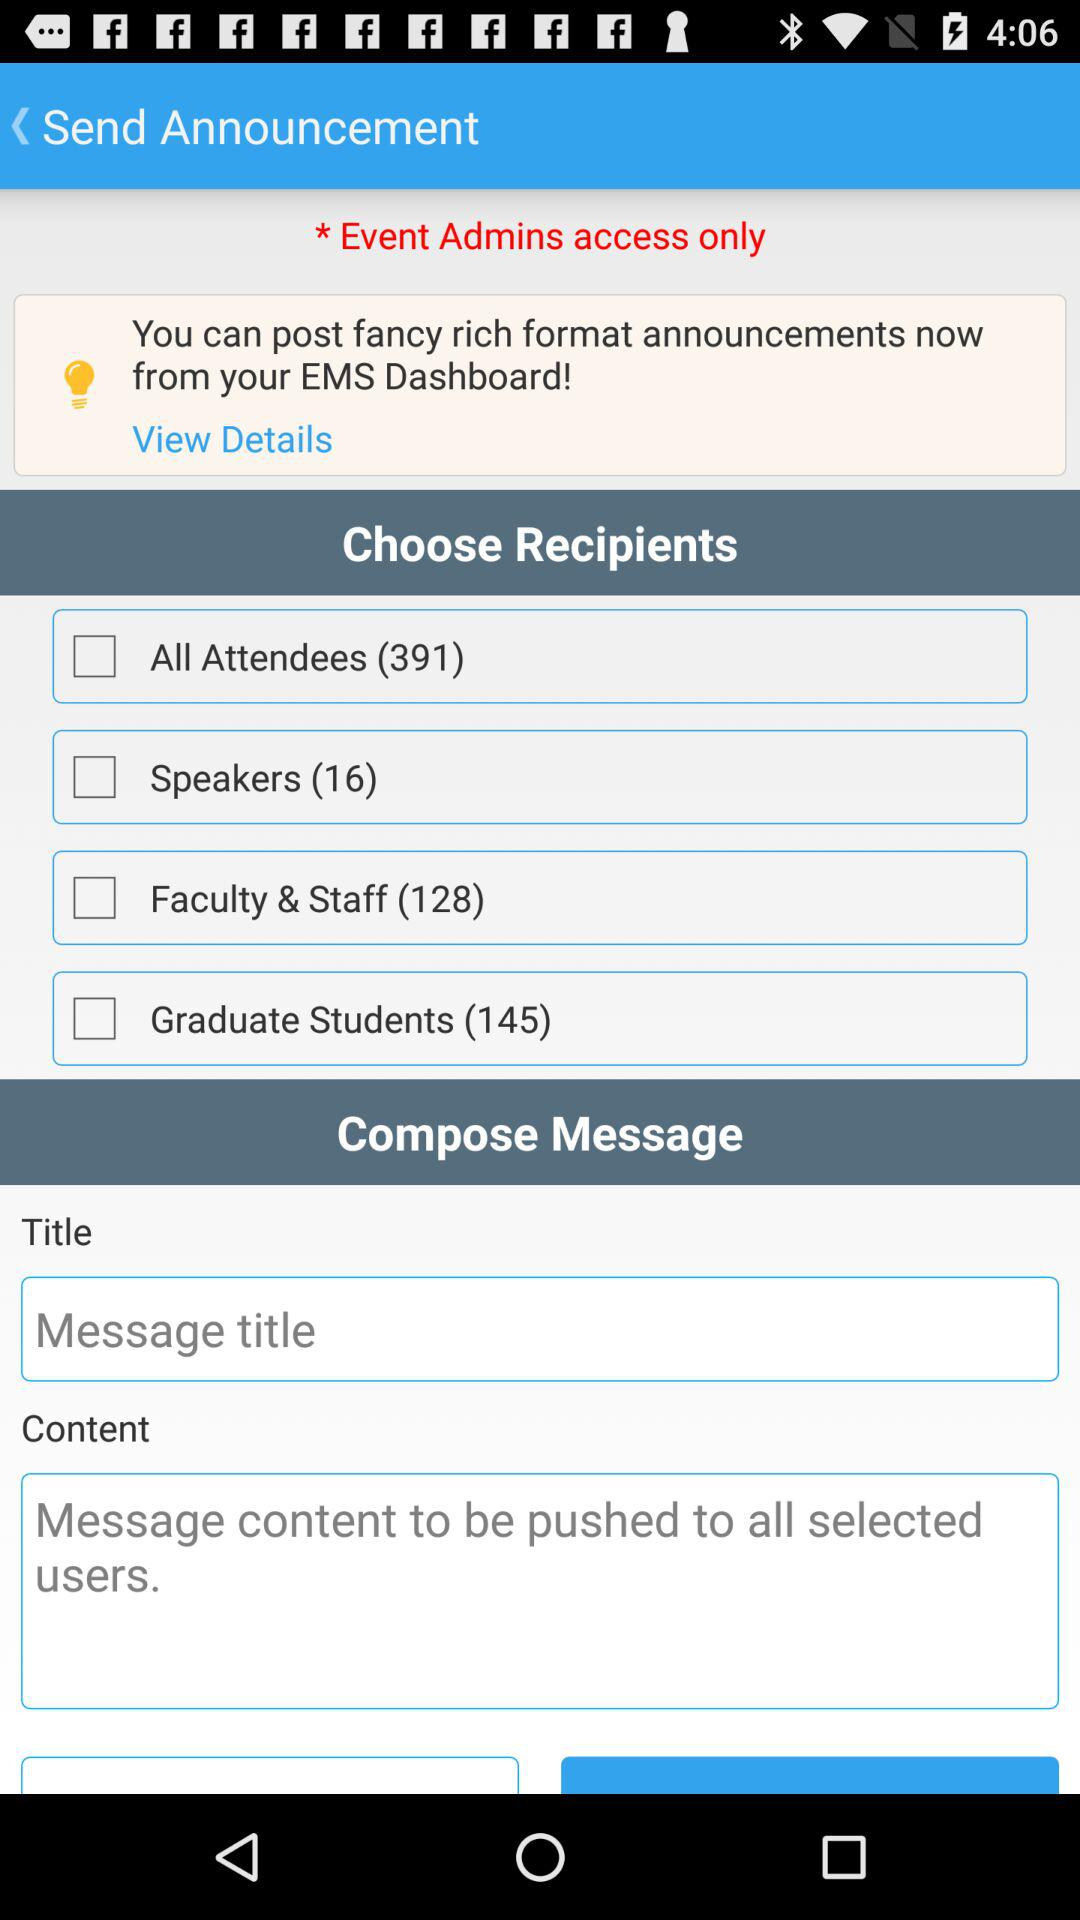How many checkboxes are there for choosing recipients?
Answer the question using a single word or phrase. 4 